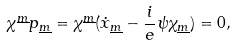Convert formula to latex. <formula><loc_0><loc_0><loc_500><loc_500>\chi ^ { \underline { m } } p _ { \underline { m } } = \chi ^ { \underline { m } } ( \dot { x } _ { \underline { m } } - { \frac { i } { e } } \psi \chi _ { \underline { m } } ) = 0 ,</formula> 